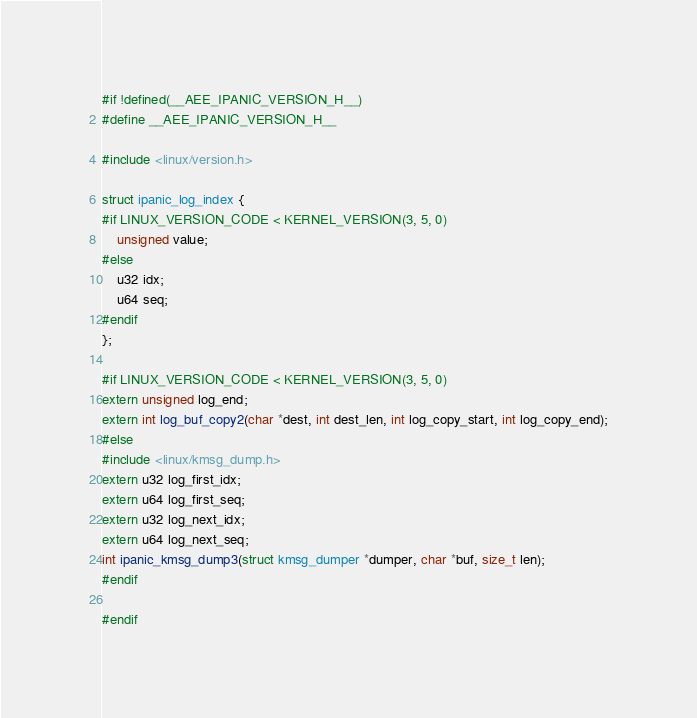Convert code to text. <code><loc_0><loc_0><loc_500><loc_500><_C_>#if !defined(__AEE_IPANIC_VERSION_H__)
#define __AEE_IPANIC_VERSION_H__

#include <linux/version.h>

struct ipanic_log_index {
#if LINUX_VERSION_CODE < KERNEL_VERSION(3, 5, 0)
	unsigned value;
#else
	u32 idx;
	u64 seq;
#endif
};

#if LINUX_VERSION_CODE < KERNEL_VERSION(3, 5, 0)
extern unsigned log_end;
extern int log_buf_copy2(char *dest, int dest_len, int log_copy_start, int log_copy_end);
#else
#include <linux/kmsg_dump.h>
extern u32 log_first_idx;
extern u64 log_first_seq;
extern u32 log_next_idx;
extern u64 log_next_seq;
int ipanic_kmsg_dump3(struct kmsg_dumper *dumper, char *buf, size_t len);
#endif

#endif
</code> 